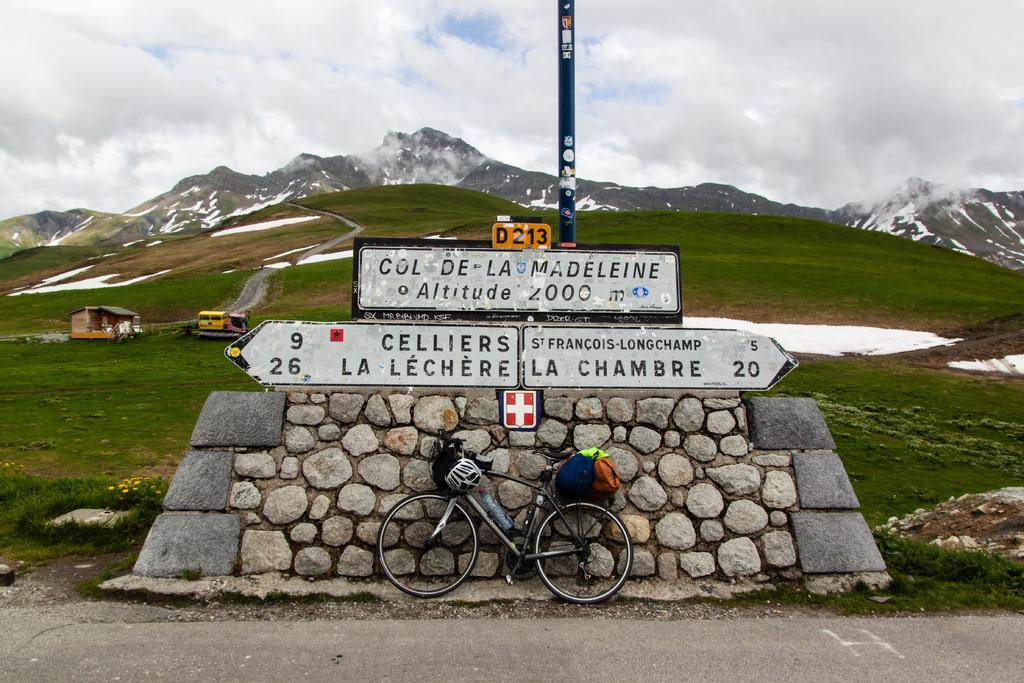Where was the image taken? The image was clicked outside. What can be seen in the middle of the image? There are mountains in the middle of the image. What is located on the left side of the image? There is a small house and a truck on the left side of the image. What mode of transportation is in the middle of the image? There is a cycle in the middle of the image. What is visible at the top of the image? The sky is visible at the top of the image. What type of vessel is used for pleasure in the image? There is no vessel present in the image, and no pleasure activity is depicted. 